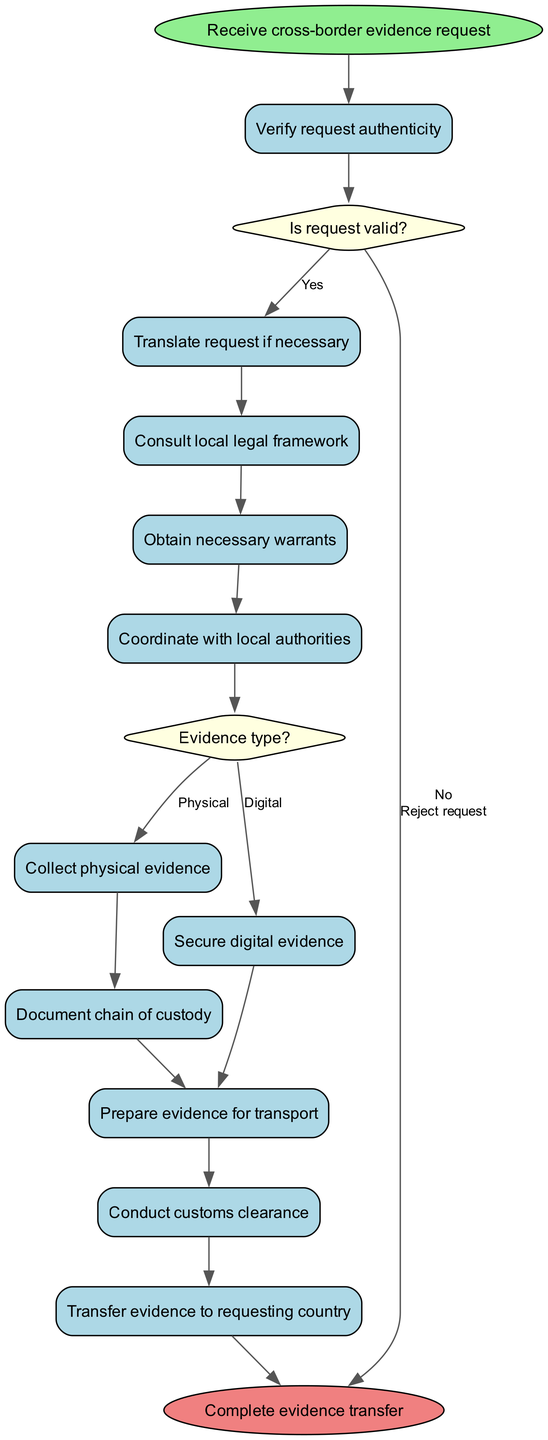What is the first activity after receiving the request? The diagram starts with the node labeled "Receive cross-border evidence request," which leads directly to the first activity, which is "Verify request authenticity."
Answer: Verify request authenticity What decision follows the verification of the request? After the activity "Verify request authenticity," the flow moves to a decision node labeled "Is request valid?" This decision determines the next steps.
Answer: Is request valid? What happens if the request is rejected? If the decision "Is request valid?" leads to "No," the next step indicated in the diagram is "Reject request," which directly connects to the end node.
Answer: Reject request How many total activities are there in the diagram? The diagram lists a total of 10 activities, counting from the start of the activities to the end, including the actions for both physical and digital evidence.
Answer: 10 Which activity comes directly after obtaining necessary warrants? The activity that follows "Obtain necessary warrants" in the diagram is "Coordinate with local authorities." There is a direct connection from one activity to the next.
Answer: Coordinate with local authorities What determines whether to collect physical evidence or secure digital evidence? The decision node labeled "Evidence type?" determines the action to take based on whether the evidence is physical or digital when flowing from "Consult local legal framework."
Answer: Evidence type? What is the final step in the evidence collection process? The last action in the activity flow before reaching the end node of the diagram is "Transfer evidence to requesting country." This is the final step in the outlined process.
Answer: Transfer evidence to requesting country How many decision nodes are in the diagram? There are 2 decision nodes in the diagram, including "Is request valid?" and "Evidence type?" which guide the flow based on yes or no conditions.
Answer: 2 What action follows securing digital evidence? The action that follows "Secure digital evidence" is "Prepare evidence for transport," as indicated by the flow in the diagram.
Answer: Prepare evidence for transport What color is the end node in the diagram? The end node is represented in light coral color according to the style definitions applied to the diagram, visually signifying the completion of the process.
Answer: light coral 